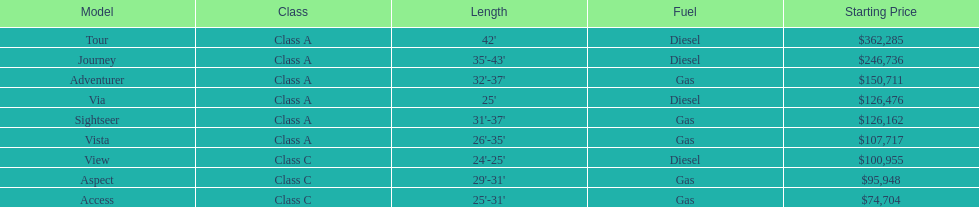How many models can be found in lengths greater than 30 feet? 7. Would you mind parsing the complete table? {'header': ['Model', 'Class', 'Length', 'Fuel', 'Starting Price'], 'rows': [['Tour', 'Class A', "42'", 'Diesel', '$362,285'], ['Journey', 'Class A', "35'-43'", 'Diesel', '$246,736'], ['Adventurer', 'Class A', "32'-37'", 'Gas', '$150,711'], ['Via', 'Class A', "25'", 'Diesel', '$126,476'], ['Sightseer', 'Class A', "31'-37'", 'Gas', '$126,162'], ['Vista', 'Class A', "26'-35'", 'Gas', '$107,717'], ['View', 'Class C', "24'-25'", 'Diesel', '$100,955'], ['Aspect', 'Class C', "29'-31'", 'Gas', '$95,948'], ['Access', 'Class C', "25'-31'", 'Gas', '$74,704']]} 